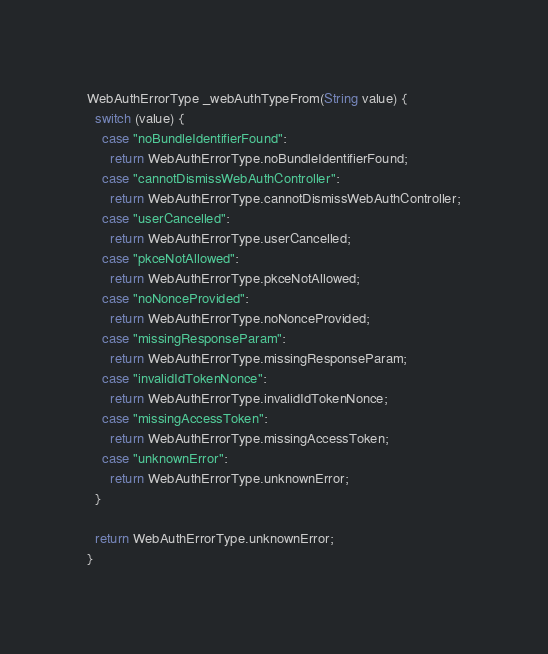Convert code to text. <code><loc_0><loc_0><loc_500><loc_500><_Dart_>
WebAuthErrorType _webAuthTypeFrom(String value) {
  switch (value) {
    case "noBundleIdentifierFound":
      return WebAuthErrorType.noBundleIdentifierFound;
    case "cannotDismissWebAuthController":
      return WebAuthErrorType.cannotDismissWebAuthController;
    case "userCancelled":
      return WebAuthErrorType.userCancelled;
    case "pkceNotAllowed":
      return WebAuthErrorType.pkceNotAllowed;
    case "noNonceProvided":
      return WebAuthErrorType.noNonceProvided;
    case "missingResponseParam":
      return WebAuthErrorType.missingResponseParam;
    case "invalidIdTokenNonce":
      return WebAuthErrorType.invalidIdTokenNonce;
    case "missingAccessToken":
      return WebAuthErrorType.missingAccessToken;
    case "unknownError":
      return WebAuthErrorType.unknownError;
  }

  return WebAuthErrorType.unknownError;
}
</code> 